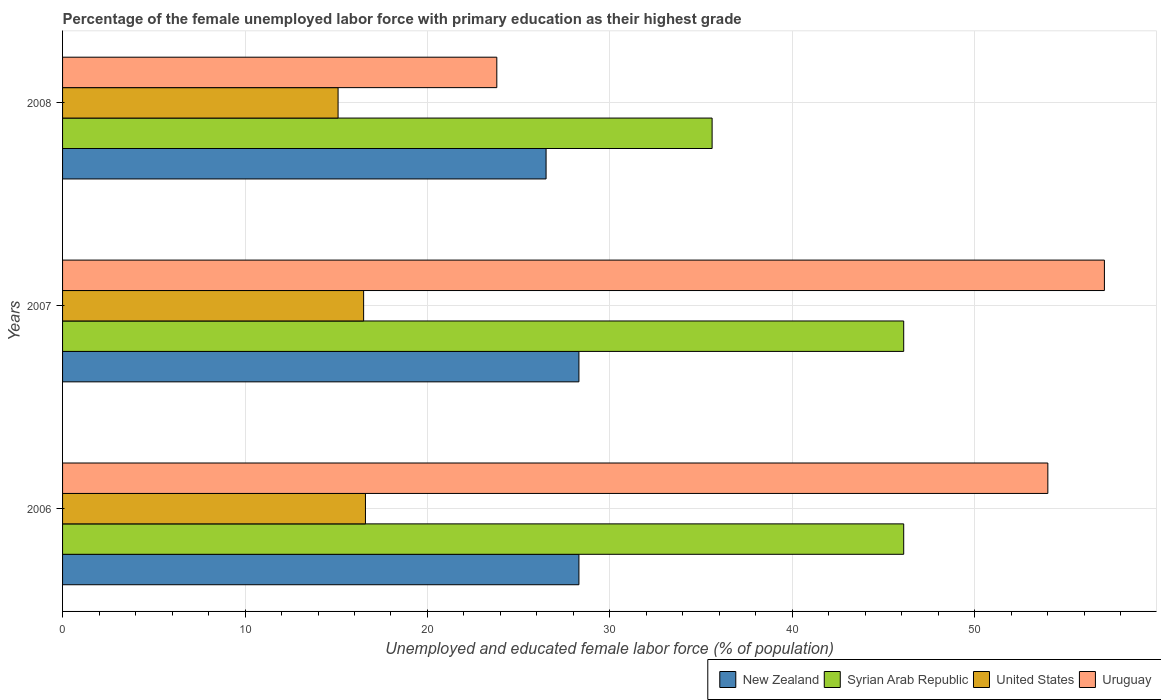How many different coloured bars are there?
Make the answer very short. 4. Are the number of bars per tick equal to the number of legend labels?
Provide a succinct answer. Yes. Are the number of bars on each tick of the Y-axis equal?
Provide a short and direct response. Yes. How many bars are there on the 2nd tick from the top?
Keep it short and to the point. 4. What is the percentage of the unemployed female labor force with primary education in United States in 2008?
Make the answer very short. 15.1. Across all years, what is the maximum percentage of the unemployed female labor force with primary education in Syrian Arab Republic?
Give a very brief answer. 46.1. Across all years, what is the minimum percentage of the unemployed female labor force with primary education in United States?
Your response must be concise. 15.1. In which year was the percentage of the unemployed female labor force with primary education in Syrian Arab Republic minimum?
Ensure brevity in your answer.  2008. What is the total percentage of the unemployed female labor force with primary education in New Zealand in the graph?
Your response must be concise. 83.1. What is the difference between the percentage of the unemployed female labor force with primary education in United States in 2006 and that in 2008?
Your response must be concise. 1.5. What is the difference between the percentage of the unemployed female labor force with primary education in United States in 2008 and the percentage of the unemployed female labor force with primary education in Syrian Arab Republic in 2007?
Your answer should be very brief. -31. What is the average percentage of the unemployed female labor force with primary education in Uruguay per year?
Offer a terse response. 44.97. In the year 2006, what is the difference between the percentage of the unemployed female labor force with primary education in Syrian Arab Republic and percentage of the unemployed female labor force with primary education in United States?
Offer a very short reply. 29.5. In how many years, is the percentage of the unemployed female labor force with primary education in United States greater than 28 %?
Your answer should be compact. 0. What is the ratio of the percentage of the unemployed female labor force with primary education in Uruguay in 2006 to that in 2008?
Give a very brief answer. 2.27. Is the percentage of the unemployed female labor force with primary education in New Zealand in 2006 less than that in 2008?
Keep it short and to the point. No. What is the difference between the highest and the second highest percentage of the unemployed female labor force with primary education in United States?
Provide a short and direct response. 0.1. What is the difference between the highest and the lowest percentage of the unemployed female labor force with primary education in Syrian Arab Republic?
Keep it short and to the point. 10.5. In how many years, is the percentage of the unemployed female labor force with primary education in Syrian Arab Republic greater than the average percentage of the unemployed female labor force with primary education in Syrian Arab Republic taken over all years?
Ensure brevity in your answer.  2. Is it the case that in every year, the sum of the percentage of the unemployed female labor force with primary education in Uruguay and percentage of the unemployed female labor force with primary education in United States is greater than the sum of percentage of the unemployed female labor force with primary education in New Zealand and percentage of the unemployed female labor force with primary education in Syrian Arab Republic?
Provide a short and direct response. Yes. What does the 2nd bar from the top in 2008 represents?
Offer a terse response. United States. What does the 3rd bar from the bottom in 2008 represents?
Keep it short and to the point. United States. Is it the case that in every year, the sum of the percentage of the unemployed female labor force with primary education in Syrian Arab Republic and percentage of the unemployed female labor force with primary education in Uruguay is greater than the percentage of the unemployed female labor force with primary education in United States?
Provide a succinct answer. Yes. How many bars are there?
Your answer should be compact. 12. How many years are there in the graph?
Ensure brevity in your answer.  3. Does the graph contain any zero values?
Your response must be concise. No. Does the graph contain grids?
Offer a terse response. Yes. Where does the legend appear in the graph?
Offer a terse response. Bottom right. How are the legend labels stacked?
Give a very brief answer. Horizontal. What is the title of the graph?
Offer a very short reply. Percentage of the female unemployed labor force with primary education as their highest grade. What is the label or title of the X-axis?
Keep it short and to the point. Unemployed and educated female labor force (% of population). What is the Unemployed and educated female labor force (% of population) in New Zealand in 2006?
Keep it short and to the point. 28.3. What is the Unemployed and educated female labor force (% of population) of Syrian Arab Republic in 2006?
Offer a very short reply. 46.1. What is the Unemployed and educated female labor force (% of population) of United States in 2006?
Make the answer very short. 16.6. What is the Unemployed and educated female labor force (% of population) of New Zealand in 2007?
Provide a short and direct response. 28.3. What is the Unemployed and educated female labor force (% of population) of Syrian Arab Republic in 2007?
Your answer should be compact. 46.1. What is the Unemployed and educated female labor force (% of population) of United States in 2007?
Your answer should be very brief. 16.5. What is the Unemployed and educated female labor force (% of population) in Uruguay in 2007?
Your answer should be compact. 57.1. What is the Unemployed and educated female labor force (% of population) of New Zealand in 2008?
Provide a succinct answer. 26.5. What is the Unemployed and educated female labor force (% of population) in Syrian Arab Republic in 2008?
Your response must be concise. 35.6. What is the Unemployed and educated female labor force (% of population) in United States in 2008?
Give a very brief answer. 15.1. What is the Unemployed and educated female labor force (% of population) in Uruguay in 2008?
Provide a succinct answer. 23.8. Across all years, what is the maximum Unemployed and educated female labor force (% of population) in New Zealand?
Make the answer very short. 28.3. Across all years, what is the maximum Unemployed and educated female labor force (% of population) of Syrian Arab Republic?
Ensure brevity in your answer.  46.1. Across all years, what is the maximum Unemployed and educated female labor force (% of population) of United States?
Keep it short and to the point. 16.6. Across all years, what is the maximum Unemployed and educated female labor force (% of population) in Uruguay?
Provide a short and direct response. 57.1. Across all years, what is the minimum Unemployed and educated female labor force (% of population) in New Zealand?
Provide a short and direct response. 26.5. Across all years, what is the minimum Unemployed and educated female labor force (% of population) of Syrian Arab Republic?
Keep it short and to the point. 35.6. Across all years, what is the minimum Unemployed and educated female labor force (% of population) of United States?
Your response must be concise. 15.1. Across all years, what is the minimum Unemployed and educated female labor force (% of population) of Uruguay?
Offer a terse response. 23.8. What is the total Unemployed and educated female labor force (% of population) in New Zealand in the graph?
Offer a terse response. 83.1. What is the total Unemployed and educated female labor force (% of population) in Syrian Arab Republic in the graph?
Your response must be concise. 127.8. What is the total Unemployed and educated female labor force (% of population) in United States in the graph?
Ensure brevity in your answer.  48.2. What is the total Unemployed and educated female labor force (% of population) of Uruguay in the graph?
Offer a terse response. 134.9. What is the difference between the Unemployed and educated female labor force (% of population) in New Zealand in 2006 and that in 2007?
Your answer should be compact. 0. What is the difference between the Unemployed and educated female labor force (% of population) in United States in 2006 and that in 2007?
Offer a terse response. 0.1. What is the difference between the Unemployed and educated female labor force (% of population) in Uruguay in 2006 and that in 2007?
Your response must be concise. -3.1. What is the difference between the Unemployed and educated female labor force (% of population) in Syrian Arab Republic in 2006 and that in 2008?
Offer a very short reply. 10.5. What is the difference between the Unemployed and educated female labor force (% of population) of Uruguay in 2006 and that in 2008?
Give a very brief answer. 30.2. What is the difference between the Unemployed and educated female labor force (% of population) of Syrian Arab Republic in 2007 and that in 2008?
Your answer should be compact. 10.5. What is the difference between the Unemployed and educated female labor force (% of population) in Uruguay in 2007 and that in 2008?
Your answer should be very brief. 33.3. What is the difference between the Unemployed and educated female labor force (% of population) of New Zealand in 2006 and the Unemployed and educated female labor force (% of population) of Syrian Arab Republic in 2007?
Provide a short and direct response. -17.8. What is the difference between the Unemployed and educated female labor force (% of population) of New Zealand in 2006 and the Unemployed and educated female labor force (% of population) of Uruguay in 2007?
Ensure brevity in your answer.  -28.8. What is the difference between the Unemployed and educated female labor force (% of population) of Syrian Arab Republic in 2006 and the Unemployed and educated female labor force (% of population) of United States in 2007?
Make the answer very short. 29.6. What is the difference between the Unemployed and educated female labor force (% of population) of United States in 2006 and the Unemployed and educated female labor force (% of population) of Uruguay in 2007?
Provide a short and direct response. -40.5. What is the difference between the Unemployed and educated female labor force (% of population) of New Zealand in 2006 and the Unemployed and educated female labor force (% of population) of United States in 2008?
Provide a succinct answer. 13.2. What is the difference between the Unemployed and educated female labor force (% of population) of Syrian Arab Republic in 2006 and the Unemployed and educated female labor force (% of population) of Uruguay in 2008?
Give a very brief answer. 22.3. What is the difference between the Unemployed and educated female labor force (% of population) in New Zealand in 2007 and the Unemployed and educated female labor force (% of population) in Syrian Arab Republic in 2008?
Provide a succinct answer. -7.3. What is the difference between the Unemployed and educated female labor force (% of population) of New Zealand in 2007 and the Unemployed and educated female labor force (% of population) of United States in 2008?
Ensure brevity in your answer.  13.2. What is the difference between the Unemployed and educated female labor force (% of population) of New Zealand in 2007 and the Unemployed and educated female labor force (% of population) of Uruguay in 2008?
Keep it short and to the point. 4.5. What is the difference between the Unemployed and educated female labor force (% of population) in Syrian Arab Republic in 2007 and the Unemployed and educated female labor force (% of population) in United States in 2008?
Provide a succinct answer. 31. What is the difference between the Unemployed and educated female labor force (% of population) in Syrian Arab Republic in 2007 and the Unemployed and educated female labor force (% of population) in Uruguay in 2008?
Give a very brief answer. 22.3. What is the average Unemployed and educated female labor force (% of population) in New Zealand per year?
Your answer should be very brief. 27.7. What is the average Unemployed and educated female labor force (% of population) in Syrian Arab Republic per year?
Ensure brevity in your answer.  42.6. What is the average Unemployed and educated female labor force (% of population) in United States per year?
Ensure brevity in your answer.  16.07. What is the average Unemployed and educated female labor force (% of population) in Uruguay per year?
Your response must be concise. 44.97. In the year 2006, what is the difference between the Unemployed and educated female labor force (% of population) of New Zealand and Unemployed and educated female labor force (% of population) of Syrian Arab Republic?
Offer a terse response. -17.8. In the year 2006, what is the difference between the Unemployed and educated female labor force (% of population) in New Zealand and Unemployed and educated female labor force (% of population) in United States?
Give a very brief answer. 11.7. In the year 2006, what is the difference between the Unemployed and educated female labor force (% of population) of New Zealand and Unemployed and educated female labor force (% of population) of Uruguay?
Your answer should be very brief. -25.7. In the year 2006, what is the difference between the Unemployed and educated female labor force (% of population) in Syrian Arab Republic and Unemployed and educated female labor force (% of population) in United States?
Ensure brevity in your answer.  29.5. In the year 2006, what is the difference between the Unemployed and educated female labor force (% of population) in United States and Unemployed and educated female labor force (% of population) in Uruguay?
Offer a terse response. -37.4. In the year 2007, what is the difference between the Unemployed and educated female labor force (% of population) in New Zealand and Unemployed and educated female labor force (% of population) in Syrian Arab Republic?
Give a very brief answer. -17.8. In the year 2007, what is the difference between the Unemployed and educated female labor force (% of population) of New Zealand and Unemployed and educated female labor force (% of population) of Uruguay?
Your answer should be compact. -28.8. In the year 2007, what is the difference between the Unemployed and educated female labor force (% of population) in Syrian Arab Republic and Unemployed and educated female labor force (% of population) in United States?
Your answer should be compact. 29.6. In the year 2007, what is the difference between the Unemployed and educated female labor force (% of population) of United States and Unemployed and educated female labor force (% of population) of Uruguay?
Make the answer very short. -40.6. In the year 2008, what is the difference between the Unemployed and educated female labor force (% of population) in New Zealand and Unemployed and educated female labor force (% of population) in Syrian Arab Republic?
Your answer should be very brief. -9.1. In the year 2008, what is the difference between the Unemployed and educated female labor force (% of population) of New Zealand and Unemployed and educated female labor force (% of population) of Uruguay?
Ensure brevity in your answer.  2.7. In the year 2008, what is the difference between the Unemployed and educated female labor force (% of population) in Syrian Arab Republic and Unemployed and educated female labor force (% of population) in United States?
Keep it short and to the point. 20.5. In the year 2008, what is the difference between the Unemployed and educated female labor force (% of population) of Syrian Arab Republic and Unemployed and educated female labor force (% of population) of Uruguay?
Your answer should be compact. 11.8. What is the ratio of the Unemployed and educated female labor force (% of population) in Syrian Arab Republic in 2006 to that in 2007?
Provide a succinct answer. 1. What is the ratio of the Unemployed and educated female labor force (% of population) in Uruguay in 2006 to that in 2007?
Your answer should be compact. 0.95. What is the ratio of the Unemployed and educated female labor force (% of population) of New Zealand in 2006 to that in 2008?
Offer a very short reply. 1.07. What is the ratio of the Unemployed and educated female labor force (% of population) of Syrian Arab Republic in 2006 to that in 2008?
Give a very brief answer. 1.29. What is the ratio of the Unemployed and educated female labor force (% of population) of United States in 2006 to that in 2008?
Give a very brief answer. 1.1. What is the ratio of the Unemployed and educated female labor force (% of population) in Uruguay in 2006 to that in 2008?
Provide a succinct answer. 2.27. What is the ratio of the Unemployed and educated female labor force (% of population) of New Zealand in 2007 to that in 2008?
Provide a succinct answer. 1.07. What is the ratio of the Unemployed and educated female labor force (% of population) in Syrian Arab Republic in 2007 to that in 2008?
Offer a terse response. 1.29. What is the ratio of the Unemployed and educated female labor force (% of population) of United States in 2007 to that in 2008?
Offer a terse response. 1.09. What is the ratio of the Unemployed and educated female labor force (% of population) in Uruguay in 2007 to that in 2008?
Keep it short and to the point. 2.4. What is the difference between the highest and the second highest Unemployed and educated female labor force (% of population) in United States?
Offer a very short reply. 0.1. What is the difference between the highest and the lowest Unemployed and educated female labor force (% of population) of New Zealand?
Provide a succinct answer. 1.8. What is the difference between the highest and the lowest Unemployed and educated female labor force (% of population) in Uruguay?
Give a very brief answer. 33.3. 